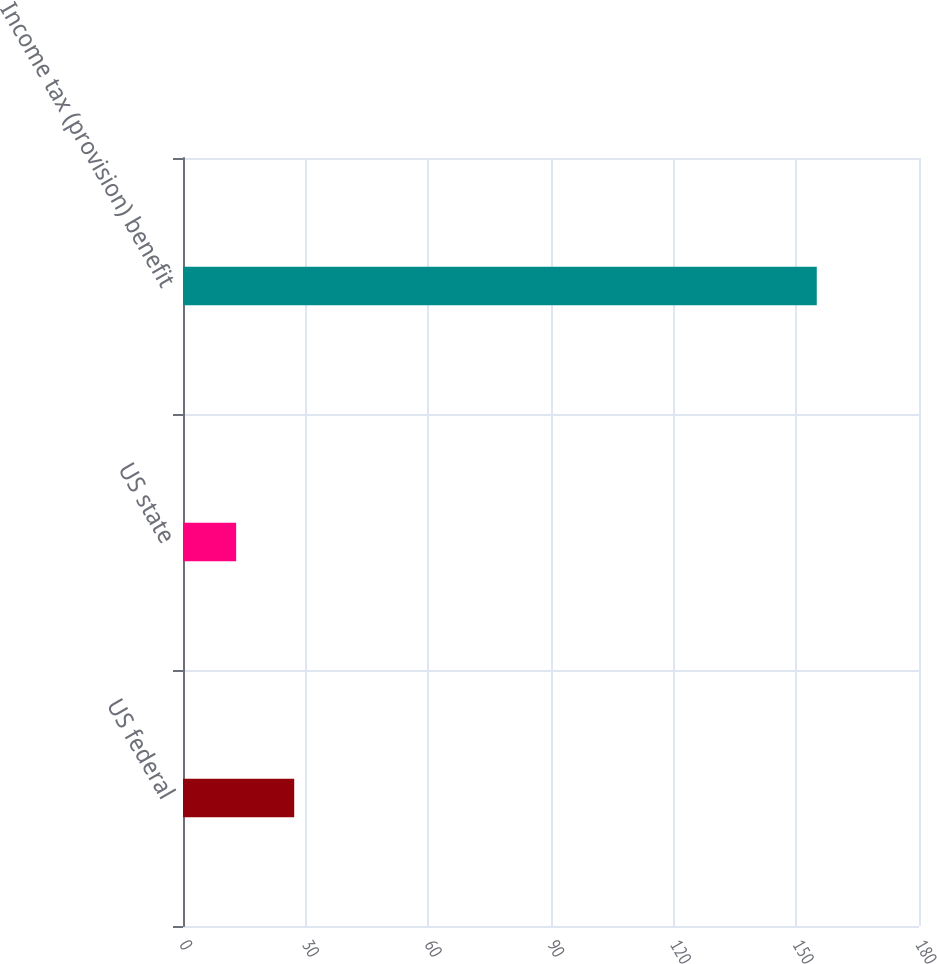Convert chart to OTSL. <chart><loc_0><loc_0><loc_500><loc_500><bar_chart><fcel>US federal<fcel>US state<fcel>Income tax (provision) benefit<nl><fcel>27.2<fcel>13<fcel>155<nl></chart> 